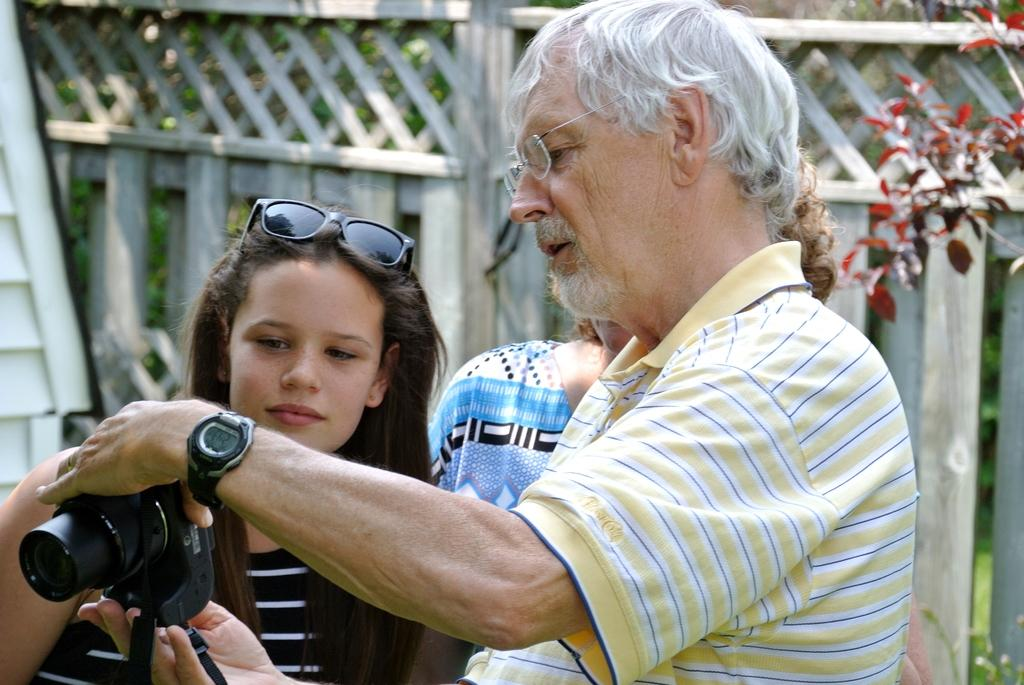How many people are in the image? There are three persons standing in the image. What is one person doing in the image? One person is holding a camera. Can you describe the person holding the camera? The person holding the camera is wearing glasses. What can be seen in the background of the image? There is a fence and trees in the background of the image. What type of bed is visible in the image? There is no bed present in the image. What action are the three persons performing together in the image? The provided facts do not mention any specific action being performed by the three persons together. 